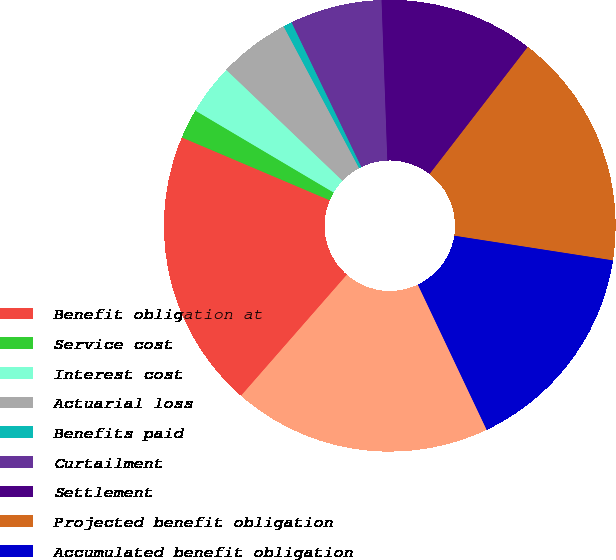<chart> <loc_0><loc_0><loc_500><loc_500><pie_chart><fcel>Benefit obligation at<fcel>Service cost<fcel>Interest cost<fcel>Actuarial loss<fcel>Benefits paid<fcel>Curtailment<fcel>Settlement<fcel>Projected benefit obligation<fcel>Accumulated benefit obligation<fcel>Fair value of plan assets at<nl><fcel>19.96%<fcel>2.12%<fcel>3.61%<fcel>5.09%<fcel>0.63%<fcel>6.58%<fcel>11.04%<fcel>16.99%<fcel>15.5%<fcel>18.48%<nl></chart> 